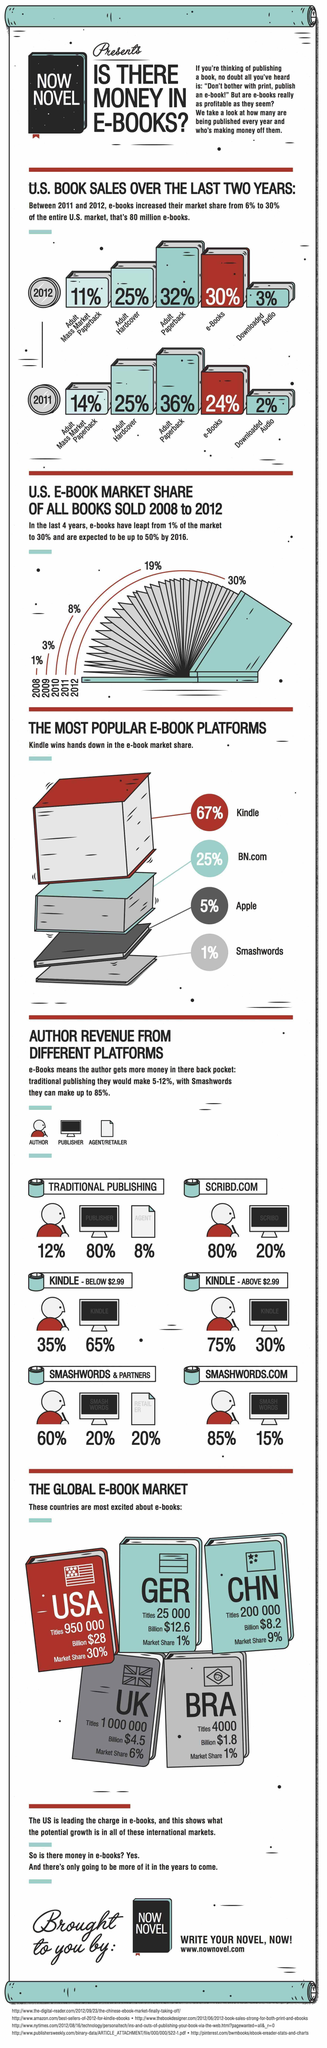What was the market share of e-books in 2009?
Answer the question with a short phrase. 3% Which e-book platform is the second highest in popularity? BN.com What was the number of titles published in Germany? 25 000 The sales of which type of book has remained the same in 2011 and 2012? Adult hardcover In which platform of publishing can the author get a share of 80%? scribd.com In which country the market share of e-books is 6%? UK What is the market share of e-books in China? 9% What was the market share of downloaded audio in 2012? 3% Through which platform of publishing does the author get the highest revenue? smashwords.com What was the e-book market share of all books sold in 2010? 8% 